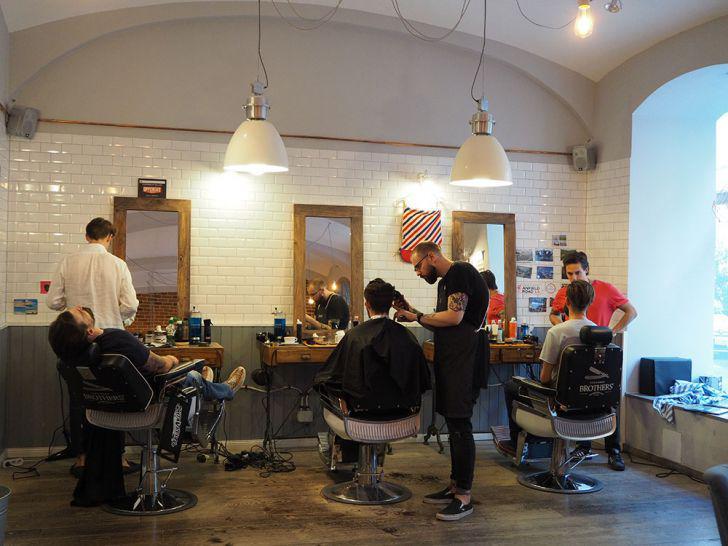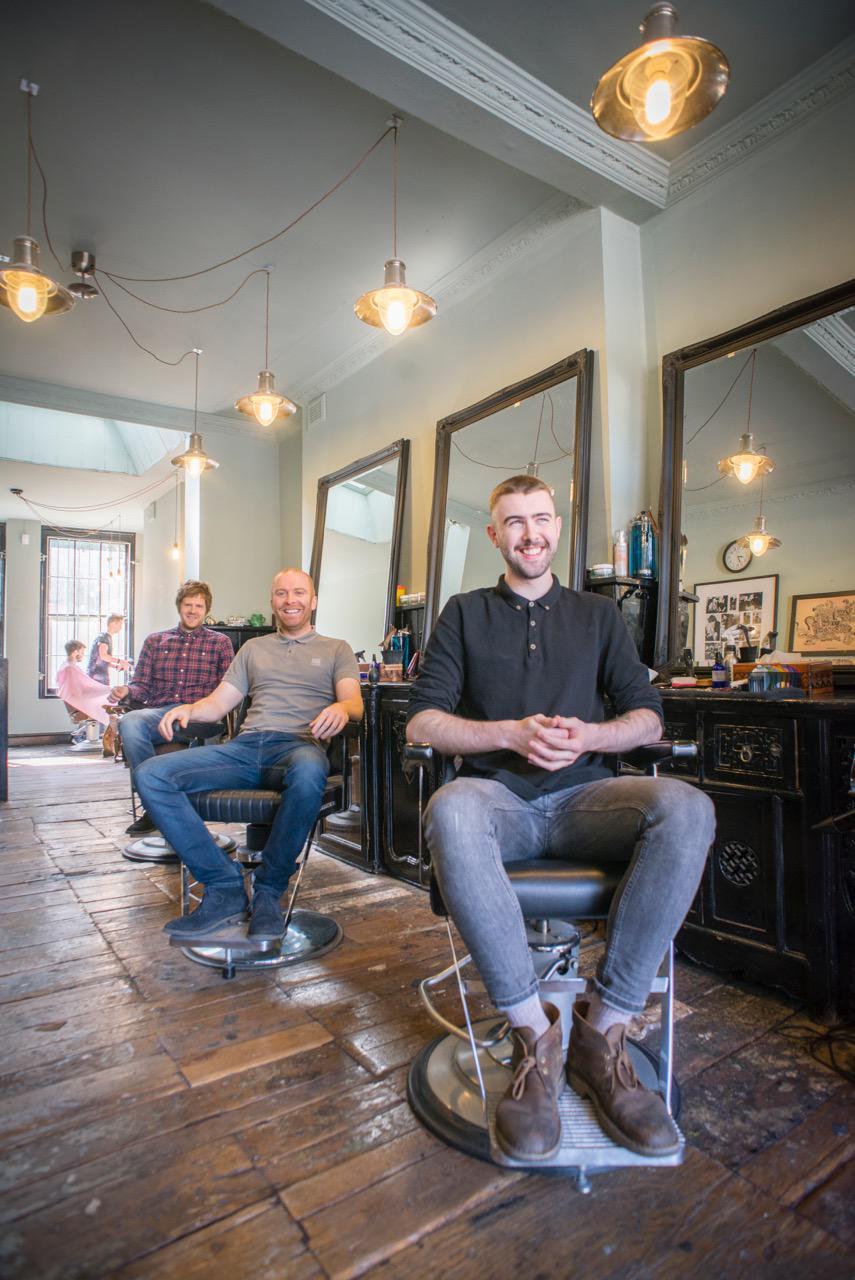The first image is the image on the left, the second image is the image on the right. Analyze the images presented: Is the assertion "In one image, men sit with their backs to the camera in front of tall rectangular wood framed mirrors." valid? Answer yes or no. Yes. The first image is the image on the left, the second image is the image on the right. For the images displayed, is the sentence "In at least one image there are a total of two black barber chairs." factually correct? Answer yes or no. No. 